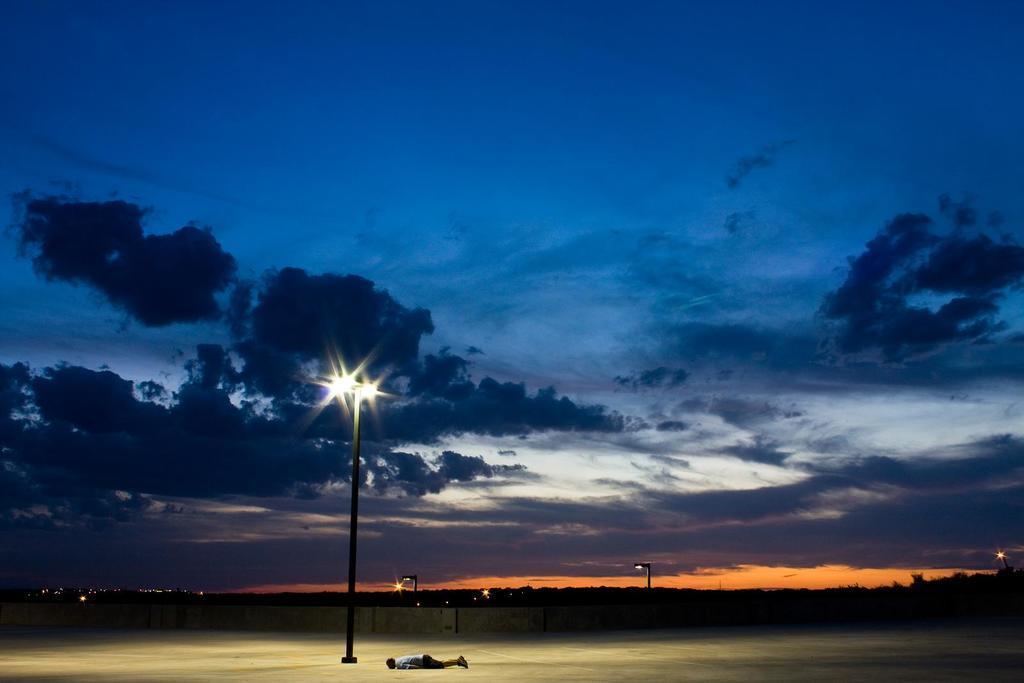Describe this image in one or two sentences. This image consists of a playground. There is a man sleeping on the ground. Beside him, there is a pole along with lights. At the top, there are clouds in the sky. In the background, there is a wall. 